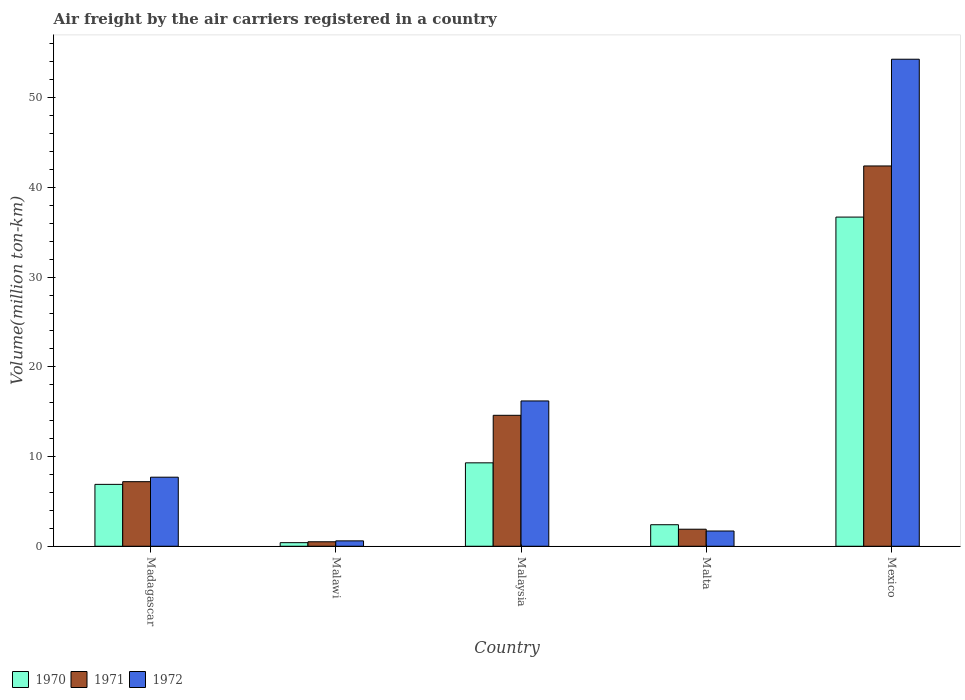Are the number of bars on each tick of the X-axis equal?
Provide a succinct answer. Yes. How many bars are there on the 3rd tick from the left?
Give a very brief answer. 3. What is the label of the 1st group of bars from the left?
Offer a very short reply. Madagascar. In how many cases, is the number of bars for a given country not equal to the number of legend labels?
Provide a short and direct response. 0. What is the volume of the air carriers in 1971 in Malaysia?
Make the answer very short. 14.6. Across all countries, what is the maximum volume of the air carriers in 1972?
Your answer should be compact. 54.3. Across all countries, what is the minimum volume of the air carriers in 1970?
Your response must be concise. 0.4. In which country was the volume of the air carriers in 1971 maximum?
Provide a succinct answer. Mexico. In which country was the volume of the air carriers in 1972 minimum?
Give a very brief answer. Malawi. What is the total volume of the air carriers in 1972 in the graph?
Keep it short and to the point. 80.5. What is the difference between the volume of the air carriers in 1972 in Madagascar and that in Mexico?
Your answer should be compact. -46.6. What is the difference between the volume of the air carriers in 1972 in Malta and the volume of the air carriers in 1971 in Mexico?
Your response must be concise. -40.7. What is the average volume of the air carriers in 1971 per country?
Ensure brevity in your answer.  13.32. What is the difference between the volume of the air carriers of/in 1971 and volume of the air carriers of/in 1970 in Malawi?
Your response must be concise. 0.1. In how many countries, is the volume of the air carriers in 1970 greater than 24 million ton-km?
Provide a short and direct response. 1. What is the ratio of the volume of the air carriers in 1971 in Madagascar to that in Mexico?
Provide a short and direct response. 0.17. Is the volume of the air carriers in 1971 in Malta less than that in Mexico?
Your answer should be very brief. Yes. Is the difference between the volume of the air carriers in 1971 in Madagascar and Malta greater than the difference between the volume of the air carriers in 1970 in Madagascar and Malta?
Provide a succinct answer. Yes. What is the difference between the highest and the second highest volume of the air carriers in 1971?
Offer a very short reply. 27.8. What is the difference between the highest and the lowest volume of the air carriers in 1971?
Offer a terse response. 41.9. In how many countries, is the volume of the air carriers in 1971 greater than the average volume of the air carriers in 1971 taken over all countries?
Give a very brief answer. 2. Is it the case that in every country, the sum of the volume of the air carriers in 1971 and volume of the air carriers in 1970 is greater than the volume of the air carriers in 1972?
Make the answer very short. Yes. Are all the bars in the graph horizontal?
Your answer should be compact. No. Does the graph contain any zero values?
Your answer should be very brief. No. Does the graph contain grids?
Offer a very short reply. No. How many legend labels are there?
Provide a short and direct response. 3. How are the legend labels stacked?
Your answer should be compact. Horizontal. What is the title of the graph?
Provide a short and direct response. Air freight by the air carriers registered in a country. Does "1964" appear as one of the legend labels in the graph?
Your response must be concise. No. What is the label or title of the Y-axis?
Ensure brevity in your answer.  Volume(million ton-km). What is the Volume(million ton-km) of 1970 in Madagascar?
Your answer should be very brief. 6.9. What is the Volume(million ton-km) in 1971 in Madagascar?
Make the answer very short. 7.2. What is the Volume(million ton-km) in 1972 in Madagascar?
Offer a terse response. 7.7. What is the Volume(million ton-km) of 1970 in Malawi?
Provide a short and direct response. 0.4. What is the Volume(million ton-km) of 1971 in Malawi?
Ensure brevity in your answer.  0.5. What is the Volume(million ton-km) in 1972 in Malawi?
Keep it short and to the point. 0.6. What is the Volume(million ton-km) in 1970 in Malaysia?
Give a very brief answer. 9.3. What is the Volume(million ton-km) in 1971 in Malaysia?
Your response must be concise. 14.6. What is the Volume(million ton-km) of 1972 in Malaysia?
Your answer should be compact. 16.2. What is the Volume(million ton-km) of 1970 in Malta?
Ensure brevity in your answer.  2.4. What is the Volume(million ton-km) in 1971 in Malta?
Provide a short and direct response. 1.9. What is the Volume(million ton-km) of 1972 in Malta?
Ensure brevity in your answer.  1.7. What is the Volume(million ton-km) of 1970 in Mexico?
Make the answer very short. 36.7. What is the Volume(million ton-km) in 1971 in Mexico?
Ensure brevity in your answer.  42.4. What is the Volume(million ton-km) of 1972 in Mexico?
Your answer should be very brief. 54.3. Across all countries, what is the maximum Volume(million ton-km) of 1970?
Your answer should be very brief. 36.7. Across all countries, what is the maximum Volume(million ton-km) of 1971?
Offer a very short reply. 42.4. Across all countries, what is the maximum Volume(million ton-km) of 1972?
Offer a terse response. 54.3. Across all countries, what is the minimum Volume(million ton-km) of 1970?
Offer a very short reply. 0.4. Across all countries, what is the minimum Volume(million ton-km) in 1971?
Your answer should be very brief. 0.5. Across all countries, what is the minimum Volume(million ton-km) of 1972?
Your answer should be compact. 0.6. What is the total Volume(million ton-km) of 1970 in the graph?
Your answer should be very brief. 55.7. What is the total Volume(million ton-km) of 1971 in the graph?
Ensure brevity in your answer.  66.6. What is the total Volume(million ton-km) in 1972 in the graph?
Provide a succinct answer. 80.5. What is the difference between the Volume(million ton-km) in 1970 in Madagascar and that in Malawi?
Your response must be concise. 6.5. What is the difference between the Volume(million ton-km) of 1970 in Madagascar and that in Malaysia?
Offer a terse response. -2.4. What is the difference between the Volume(million ton-km) of 1971 in Madagascar and that in Malaysia?
Provide a succinct answer. -7.4. What is the difference between the Volume(million ton-km) of 1970 in Madagascar and that in Malta?
Your answer should be very brief. 4.5. What is the difference between the Volume(million ton-km) in 1970 in Madagascar and that in Mexico?
Make the answer very short. -29.8. What is the difference between the Volume(million ton-km) in 1971 in Madagascar and that in Mexico?
Provide a succinct answer. -35.2. What is the difference between the Volume(million ton-km) of 1972 in Madagascar and that in Mexico?
Ensure brevity in your answer.  -46.6. What is the difference between the Volume(million ton-km) of 1970 in Malawi and that in Malaysia?
Offer a very short reply. -8.9. What is the difference between the Volume(million ton-km) in 1971 in Malawi and that in Malaysia?
Offer a terse response. -14.1. What is the difference between the Volume(million ton-km) of 1972 in Malawi and that in Malaysia?
Keep it short and to the point. -15.6. What is the difference between the Volume(million ton-km) in 1971 in Malawi and that in Malta?
Your answer should be compact. -1.4. What is the difference between the Volume(million ton-km) in 1972 in Malawi and that in Malta?
Make the answer very short. -1.1. What is the difference between the Volume(million ton-km) in 1970 in Malawi and that in Mexico?
Offer a very short reply. -36.3. What is the difference between the Volume(million ton-km) of 1971 in Malawi and that in Mexico?
Your response must be concise. -41.9. What is the difference between the Volume(million ton-km) in 1972 in Malawi and that in Mexico?
Offer a very short reply. -53.7. What is the difference between the Volume(million ton-km) in 1970 in Malaysia and that in Mexico?
Your answer should be compact. -27.4. What is the difference between the Volume(million ton-km) in 1971 in Malaysia and that in Mexico?
Keep it short and to the point. -27.8. What is the difference between the Volume(million ton-km) in 1972 in Malaysia and that in Mexico?
Your answer should be compact. -38.1. What is the difference between the Volume(million ton-km) in 1970 in Malta and that in Mexico?
Keep it short and to the point. -34.3. What is the difference between the Volume(million ton-km) of 1971 in Malta and that in Mexico?
Make the answer very short. -40.5. What is the difference between the Volume(million ton-km) of 1972 in Malta and that in Mexico?
Give a very brief answer. -52.6. What is the difference between the Volume(million ton-km) of 1971 in Madagascar and the Volume(million ton-km) of 1972 in Malawi?
Provide a succinct answer. 6.6. What is the difference between the Volume(million ton-km) in 1970 in Madagascar and the Volume(million ton-km) in 1971 in Malaysia?
Your response must be concise. -7.7. What is the difference between the Volume(million ton-km) in 1971 in Madagascar and the Volume(million ton-km) in 1972 in Malaysia?
Provide a short and direct response. -9. What is the difference between the Volume(million ton-km) of 1970 in Madagascar and the Volume(million ton-km) of 1971 in Malta?
Keep it short and to the point. 5. What is the difference between the Volume(million ton-km) of 1971 in Madagascar and the Volume(million ton-km) of 1972 in Malta?
Ensure brevity in your answer.  5.5. What is the difference between the Volume(million ton-km) of 1970 in Madagascar and the Volume(million ton-km) of 1971 in Mexico?
Make the answer very short. -35.5. What is the difference between the Volume(million ton-km) in 1970 in Madagascar and the Volume(million ton-km) in 1972 in Mexico?
Give a very brief answer. -47.4. What is the difference between the Volume(million ton-km) in 1971 in Madagascar and the Volume(million ton-km) in 1972 in Mexico?
Keep it short and to the point. -47.1. What is the difference between the Volume(million ton-km) in 1970 in Malawi and the Volume(million ton-km) in 1972 in Malaysia?
Offer a terse response. -15.8. What is the difference between the Volume(million ton-km) of 1971 in Malawi and the Volume(million ton-km) of 1972 in Malaysia?
Offer a very short reply. -15.7. What is the difference between the Volume(million ton-km) in 1970 in Malawi and the Volume(million ton-km) in 1971 in Malta?
Offer a very short reply. -1.5. What is the difference between the Volume(million ton-km) in 1970 in Malawi and the Volume(million ton-km) in 1972 in Malta?
Keep it short and to the point. -1.3. What is the difference between the Volume(million ton-km) in 1971 in Malawi and the Volume(million ton-km) in 1972 in Malta?
Your answer should be very brief. -1.2. What is the difference between the Volume(million ton-km) of 1970 in Malawi and the Volume(million ton-km) of 1971 in Mexico?
Make the answer very short. -42. What is the difference between the Volume(million ton-km) in 1970 in Malawi and the Volume(million ton-km) in 1972 in Mexico?
Offer a terse response. -53.9. What is the difference between the Volume(million ton-km) in 1971 in Malawi and the Volume(million ton-km) in 1972 in Mexico?
Offer a terse response. -53.8. What is the difference between the Volume(million ton-km) of 1970 in Malaysia and the Volume(million ton-km) of 1971 in Malta?
Provide a succinct answer. 7.4. What is the difference between the Volume(million ton-km) in 1970 in Malaysia and the Volume(million ton-km) in 1972 in Malta?
Give a very brief answer. 7.6. What is the difference between the Volume(million ton-km) of 1970 in Malaysia and the Volume(million ton-km) of 1971 in Mexico?
Your response must be concise. -33.1. What is the difference between the Volume(million ton-km) in 1970 in Malaysia and the Volume(million ton-km) in 1972 in Mexico?
Keep it short and to the point. -45. What is the difference between the Volume(million ton-km) in 1971 in Malaysia and the Volume(million ton-km) in 1972 in Mexico?
Your answer should be compact. -39.7. What is the difference between the Volume(million ton-km) in 1970 in Malta and the Volume(million ton-km) in 1971 in Mexico?
Your answer should be compact. -40. What is the difference between the Volume(million ton-km) in 1970 in Malta and the Volume(million ton-km) in 1972 in Mexico?
Make the answer very short. -51.9. What is the difference between the Volume(million ton-km) in 1971 in Malta and the Volume(million ton-km) in 1972 in Mexico?
Offer a terse response. -52.4. What is the average Volume(million ton-km) in 1970 per country?
Provide a short and direct response. 11.14. What is the average Volume(million ton-km) of 1971 per country?
Give a very brief answer. 13.32. What is the average Volume(million ton-km) of 1972 per country?
Make the answer very short. 16.1. What is the difference between the Volume(million ton-km) of 1970 and Volume(million ton-km) of 1971 in Madagascar?
Your response must be concise. -0.3. What is the difference between the Volume(million ton-km) in 1971 and Volume(million ton-km) in 1972 in Madagascar?
Keep it short and to the point. -0.5. What is the difference between the Volume(million ton-km) of 1970 and Volume(million ton-km) of 1971 in Malaysia?
Provide a succinct answer. -5.3. What is the difference between the Volume(million ton-km) in 1970 and Volume(million ton-km) in 1972 in Malaysia?
Provide a succinct answer. -6.9. What is the difference between the Volume(million ton-km) of 1971 and Volume(million ton-km) of 1972 in Malaysia?
Provide a short and direct response. -1.6. What is the difference between the Volume(million ton-km) of 1970 and Volume(million ton-km) of 1971 in Malta?
Your answer should be very brief. 0.5. What is the difference between the Volume(million ton-km) in 1970 and Volume(million ton-km) in 1972 in Malta?
Keep it short and to the point. 0.7. What is the difference between the Volume(million ton-km) of 1971 and Volume(million ton-km) of 1972 in Malta?
Offer a very short reply. 0.2. What is the difference between the Volume(million ton-km) in 1970 and Volume(million ton-km) in 1971 in Mexico?
Provide a succinct answer. -5.7. What is the difference between the Volume(million ton-km) of 1970 and Volume(million ton-km) of 1972 in Mexico?
Ensure brevity in your answer.  -17.6. What is the difference between the Volume(million ton-km) in 1971 and Volume(million ton-km) in 1972 in Mexico?
Offer a terse response. -11.9. What is the ratio of the Volume(million ton-km) in 1970 in Madagascar to that in Malawi?
Offer a very short reply. 17.25. What is the ratio of the Volume(million ton-km) of 1972 in Madagascar to that in Malawi?
Offer a very short reply. 12.83. What is the ratio of the Volume(million ton-km) of 1970 in Madagascar to that in Malaysia?
Provide a succinct answer. 0.74. What is the ratio of the Volume(million ton-km) of 1971 in Madagascar to that in Malaysia?
Offer a terse response. 0.49. What is the ratio of the Volume(million ton-km) in 1972 in Madagascar to that in Malaysia?
Ensure brevity in your answer.  0.48. What is the ratio of the Volume(million ton-km) in 1970 in Madagascar to that in Malta?
Offer a terse response. 2.88. What is the ratio of the Volume(million ton-km) in 1971 in Madagascar to that in Malta?
Ensure brevity in your answer.  3.79. What is the ratio of the Volume(million ton-km) of 1972 in Madagascar to that in Malta?
Give a very brief answer. 4.53. What is the ratio of the Volume(million ton-km) of 1970 in Madagascar to that in Mexico?
Offer a very short reply. 0.19. What is the ratio of the Volume(million ton-km) in 1971 in Madagascar to that in Mexico?
Provide a short and direct response. 0.17. What is the ratio of the Volume(million ton-km) in 1972 in Madagascar to that in Mexico?
Give a very brief answer. 0.14. What is the ratio of the Volume(million ton-km) in 1970 in Malawi to that in Malaysia?
Give a very brief answer. 0.04. What is the ratio of the Volume(million ton-km) of 1971 in Malawi to that in Malaysia?
Ensure brevity in your answer.  0.03. What is the ratio of the Volume(million ton-km) in 1972 in Malawi to that in Malaysia?
Keep it short and to the point. 0.04. What is the ratio of the Volume(million ton-km) in 1970 in Malawi to that in Malta?
Make the answer very short. 0.17. What is the ratio of the Volume(million ton-km) in 1971 in Malawi to that in Malta?
Your answer should be very brief. 0.26. What is the ratio of the Volume(million ton-km) in 1972 in Malawi to that in Malta?
Offer a very short reply. 0.35. What is the ratio of the Volume(million ton-km) in 1970 in Malawi to that in Mexico?
Offer a terse response. 0.01. What is the ratio of the Volume(million ton-km) of 1971 in Malawi to that in Mexico?
Provide a short and direct response. 0.01. What is the ratio of the Volume(million ton-km) of 1972 in Malawi to that in Mexico?
Ensure brevity in your answer.  0.01. What is the ratio of the Volume(million ton-km) of 1970 in Malaysia to that in Malta?
Your answer should be compact. 3.88. What is the ratio of the Volume(million ton-km) of 1971 in Malaysia to that in Malta?
Offer a terse response. 7.68. What is the ratio of the Volume(million ton-km) in 1972 in Malaysia to that in Malta?
Make the answer very short. 9.53. What is the ratio of the Volume(million ton-km) in 1970 in Malaysia to that in Mexico?
Offer a very short reply. 0.25. What is the ratio of the Volume(million ton-km) in 1971 in Malaysia to that in Mexico?
Your answer should be very brief. 0.34. What is the ratio of the Volume(million ton-km) in 1972 in Malaysia to that in Mexico?
Your answer should be very brief. 0.3. What is the ratio of the Volume(million ton-km) in 1970 in Malta to that in Mexico?
Your answer should be compact. 0.07. What is the ratio of the Volume(million ton-km) of 1971 in Malta to that in Mexico?
Your response must be concise. 0.04. What is the ratio of the Volume(million ton-km) of 1972 in Malta to that in Mexico?
Your response must be concise. 0.03. What is the difference between the highest and the second highest Volume(million ton-km) of 1970?
Your answer should be very brief. 27.4. What is the difference between the highest and the second highest Volume(million ton-km) in 1971?
Your response must be concise. 27.8. What is the difference between the highest and the second highest Volume(million ton-km) in 1972?
Give a very brief answer. 38.1. What is the difference between the highest and the lowest Volume(million ton-km) of 1970?
Provide a succinct answer. 36.3. What is the difference between the highest and the lowest Volume(million ton-km) of 1971?
Offer a terse response. 41.9. What is the difference between the highest and the lowest Volume(million ton-km) of 1972?
Your answer should be compact. 53.7. 